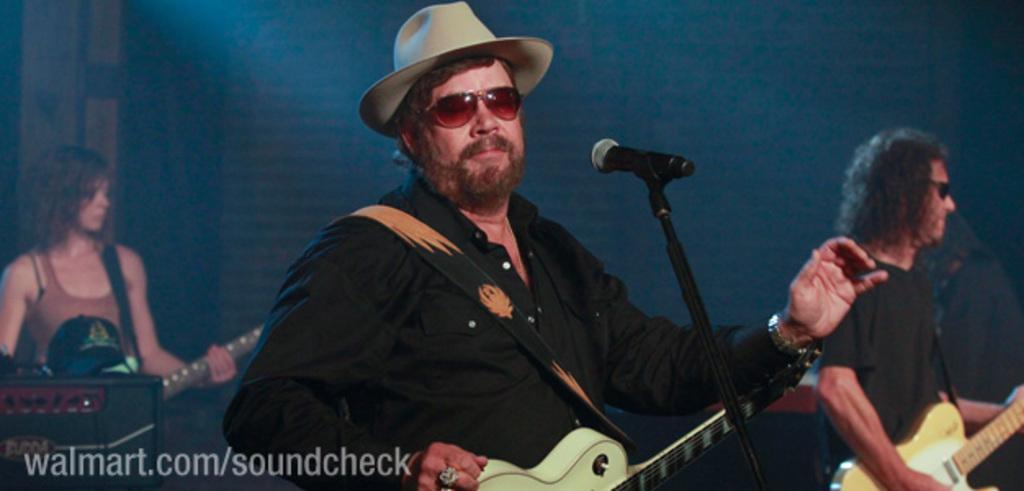Describe this image in one or two sentences. In this picture we can see three persons are standing and playing guitar. In the middle of the image a man is wearing hat and goggles, in-front of him we can see a mic with stand. On the left side of the image we can see a musical instrument and cap. In the bottom left corner we can see the text. In the background the image is dark. 